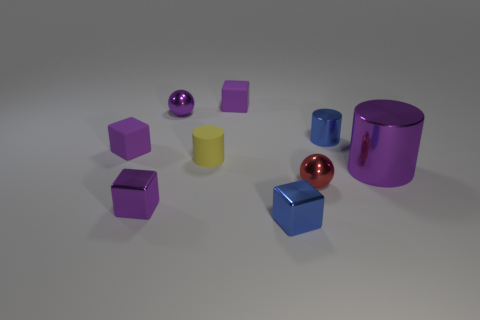Subtract all green cylinders. How many purple blocks are left? 3 Subtract all tiny purple metal blocks. How many blocks are left? 3 Subtract all cyan cubes. Subtract all blue cylinders. How many cubes are left? 4 Add 1 red shiny spheres. How many objects exist? 10 Subtract all balls. How many objects are left? 7 Subtract 0 brown cylinders. How many objects are left? 9 Subtract all small matte blocks. Subtract all tiny blue metal cylinders. How many objects are left? 6 Add 4 red metallic objects. How many red metallic objects are left? 5 Add 3 green spheres. How many green spheres exist? 3 